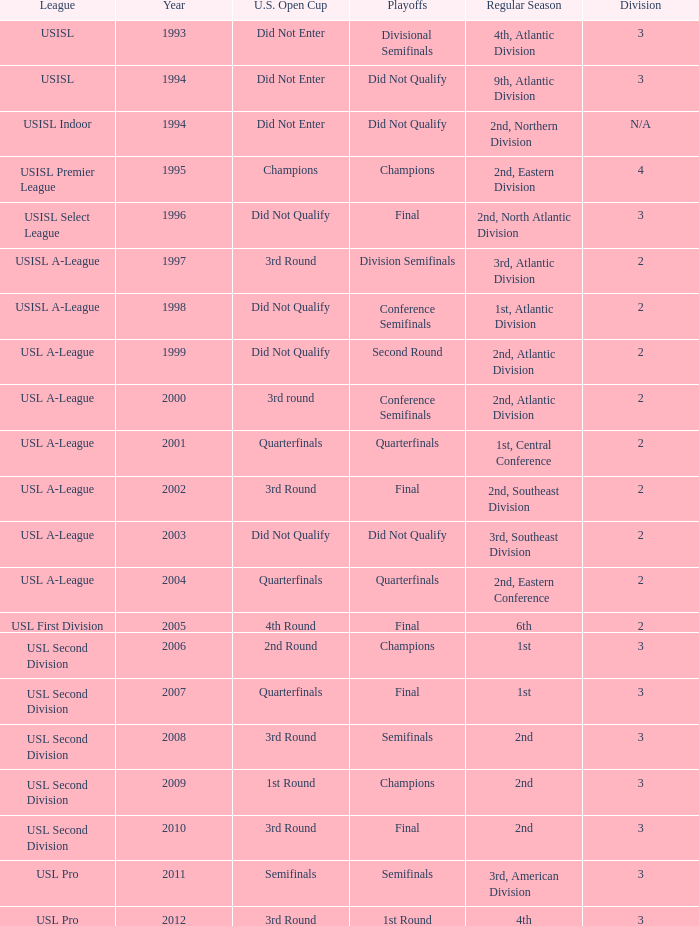What's the u.s. open cup status for regular season of 4th, atlantic division  Did Not Enter. Write the full table. {'header': ['League', 'Year', 'U.S. Open Cup', 'Playoffs', 'Regular Season', 'Division'], 'rows': [['USISL', '1993', 'Did Not Enter', 'Divisional Semifinals', '4th, Atlantic Division', '3'], ['USISL', '1994', 'Did Not Enter', 'Did Not Qualify', '9th, Atlantic Division', '3'], ['USISL Indoor', '1994', 'Did Not Enter', 'Did Not Qualify', '2nd, Northern Division', 'N/A'], ['USISL Premier League', '1995', 'Champions', 'Champions', '2nd, Eastern Division', '4'], ['USISL Select League', '1996', 'Did Not Qualify', 'Final', '2nd, North Atlantic Division', '3'], ['USISL A-League', '1997', '3rd Round', 'Division Semifinals', '3rd, Atlantic Division', '2'], ['USISL A-League', '1998', 'Did Not Qualify', 'Conference Semifinals', '1st, Atlantic Division', '2'], ['USL A-League', '1999', 'Did Not Qualify', 'Second Round', '2nd, Atlantic Division', '2'], ['USL A-League', '2000', '3rd round', 'Conference Semifinals', '2nd, Atlantic Division', '2'], ['USL A-League', '2001', 'Quarterfinals', 'Quarterfinals', '1st, Central Conference', '2'], ['USL A-League', '2002', '3rd Round', 'Final', '2nd, Southeast Division', '2'], ['USL A-League', '2003', 'Did Not Qualify', 'Did Not Qualify', '3rd, Southeast Division', '2'], ['USL A-League', '2004', 'Quarterfinals', 'Quarterfinals', '2nd, Eastern Conference', '2'], ['USL First Division', '2005', '4th Round', 'Final', '6th', '2'], ['USL Second Division', '2006', '2nd Round', 'Champions', '1st', '3'], ['USL Second Division', '2007', 'Quarterfinals', 'Final', '1st', '3'], ['USL Second Division', '2008', '3rd Round', 'Semifinals', '2nd', '3'], ['USL Second Division', '2009', '1st Round', 'Champions', '2nd', '3'], ['USL Second Division', '2010', '3rd Round', 'Final', '2nd', '3'], ['USL Pro', '2011', 'Semifinals', 'Semifinals', '3rd, American Division', '3'], ['USL Pro', '2012', '3rd Round', '1st Round', '4th', '3']]} 